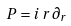Convert formula to latex. <formula><loc_0><loc_0><loc_500><loc_500>P = i \, r \, \partial _ { r }</formula> 